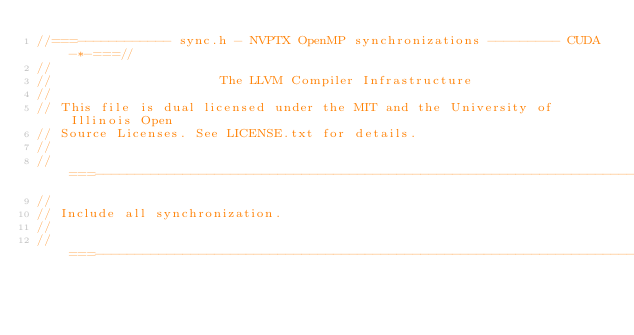<code> <loc_0><loc_0><loc_500><loc_500><_Cuda_>//===------------ sync.h - NVPTX OpenMP synchronizations --------- CUDA -*-===//
//
//                     The LLVM Compiler Infrastructure
//
// This file is dual licensed under the MIT and the University of Illinois Open
// Source Licenses. See LICENSE.txt for details.
//
//===----------------------------------------------------------------------===//
//
// Include all synchronization.
//
//===----------------------------------------------------------------------===//
</code> 